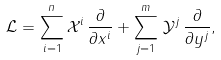<formula> <loc_0><loc_0><loc_500><loc_500>\mathcal { L } = \sum _ { i = 1 } ^ { n } \mathcal { X } ^ { i } \, \frac { \partial } { \partial x ^ { i } } + \sum _ { j = 1 } ^ { m } \, \mathcal { Y } ^ { j } \, \frac { \partial } { \partial y ^ { j } } ,</formula> 